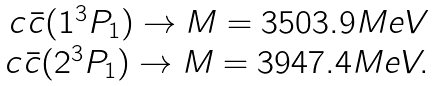Convert formula to latex. <formula><loc_0><loc_0><loc_500><loc_500>\begin{array} { r c l } c \bar { c } ( 1 ^ { 3 } P _ { 1 } ) \to M = 3 5 0 3 . 9 M e V \\ c \bar { c } ( 2 ^ { 3 } P _ { 1 } ) \to M = 3 9 4 7 . 4 M e V . \end{array}</formula> 